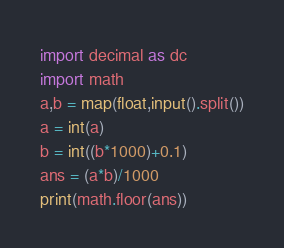<code> <loc_0><loc_0><loc_500><loc_500><_Python_>import decimal as dc
import math
a,b = map(float,input().split())
a = int(a)
b = int((b*1000)+0.1)
ans = (a*b)/1000
print(math.floor(ans))</code> 